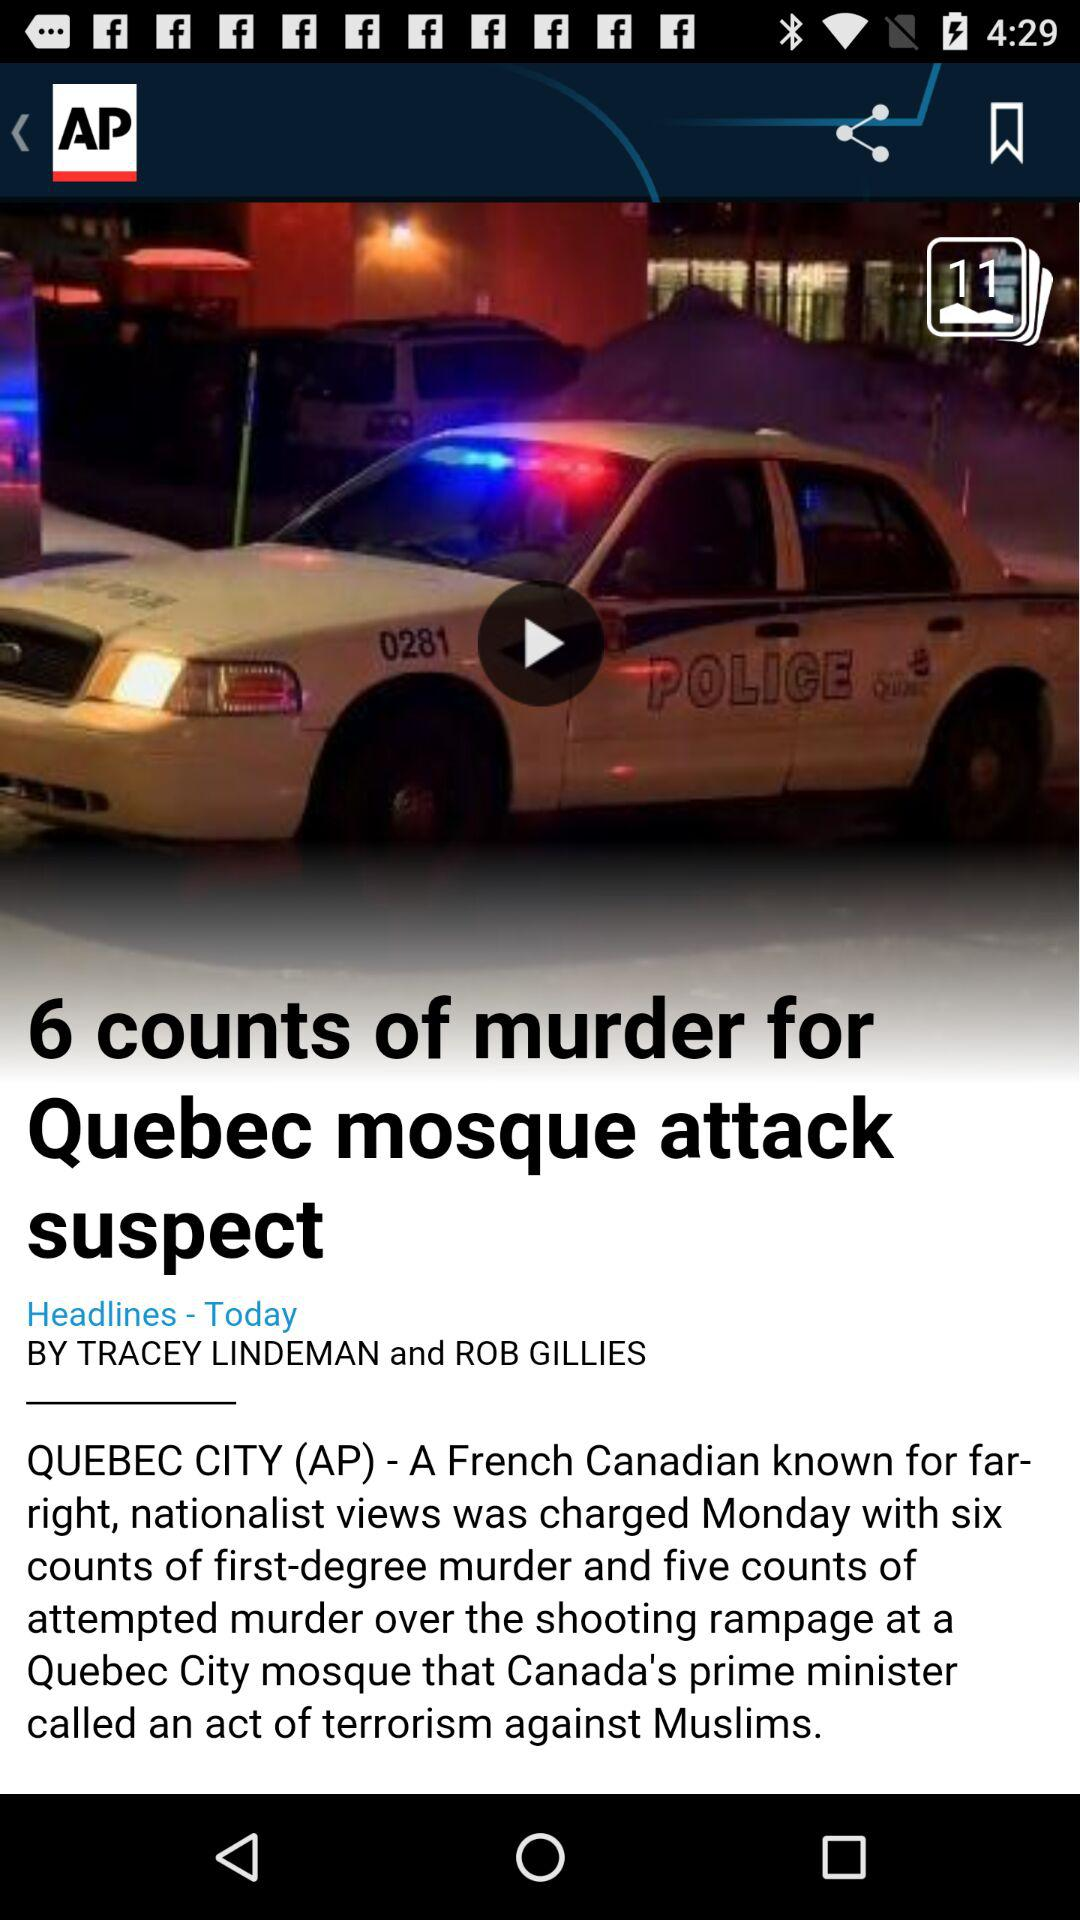What is the name of the news app? The name of the news app is "AP News". 